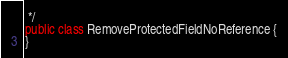<code> <loc_0><loc_0><loc_500><loc_500><_Java_> */
public class RemoveProtectedFieldNoReference {
}
</code> 